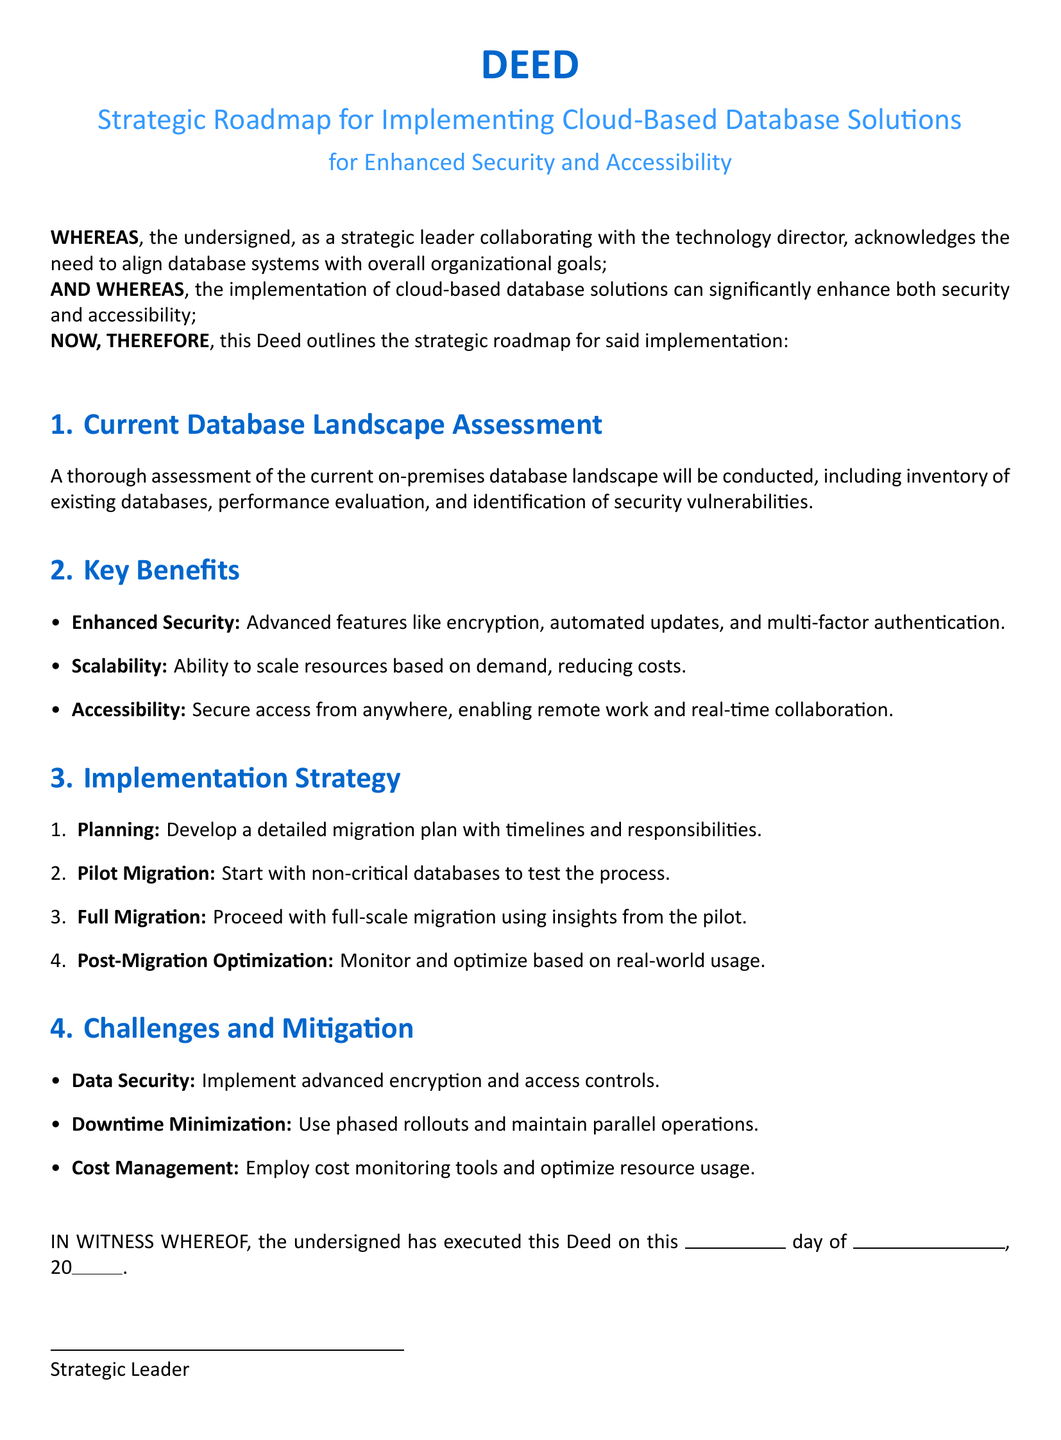What is the title of the Deed? The title of the Deed is stated clearly at the beginning of the document, which outlines its primary focus.
Answer: Strategic Roadmap for Implementing Cloud-Based Database Solutions What is the main purpose of this Deed? The purpose of the Deed is to align database systems with organizational goals and enhance security and accessibility through cloud-based solutions.
Answer: Align database systems with overall organizational goals What section outlines the implementation strategy? The section that details the steps to realize the implementation is specified within the document as part of the strategic roadmap.
Answer: Implementation Strategy What is the first step in the implementation strategy? The first step is identified in the enumeration of actions that lead to the migration to cloud-based systems.
Answer: Planning Which benefits enhance security according to the document? The document lists specific features that augment security in database solutions, highlighting their importance.
Answer: Advanced features like encryption, automated updates, and multi-factor authentication What is one of the challenges mentioned in the Deed? The Deed outlines various potential challenges alongside mitigation strategies, highlighting critical concerns during implementation.
Answer: Data Security What type of document is this? The specific nature of the document can be identified by its structure and stated purpose, putting it into a formal context.
Answer: Deed How many main sections are listed in the document? The number of distinct segments or categories presented in the roadmap gives insight into the organization of the content.
Answer: Four 